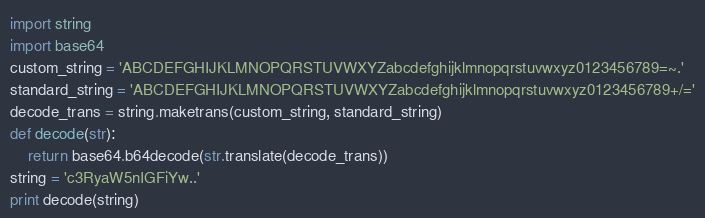<code> <loc_0><loc_0><loc_500><loc_500><_Python_>import string
import base64
custom_string = 'ABCDEFGHIJKLMNOPQRSTUVWXYZabcdefghijklmnopqrstuvwxyz0123456789=~.'
standard_string = 'ABCDEFGHIJKLMNOPQRSTUVWXYZabcdefghijklmnopqrstuvwxyz0123456789+/='
decode_trans = string.maketrans(custom_string, standard_string)
def decode(str):
    return base64.b64decode(str.translate(decode_trans))
string = 'c3RyaW5nIGFiYw..'
print decode(string)</code> 